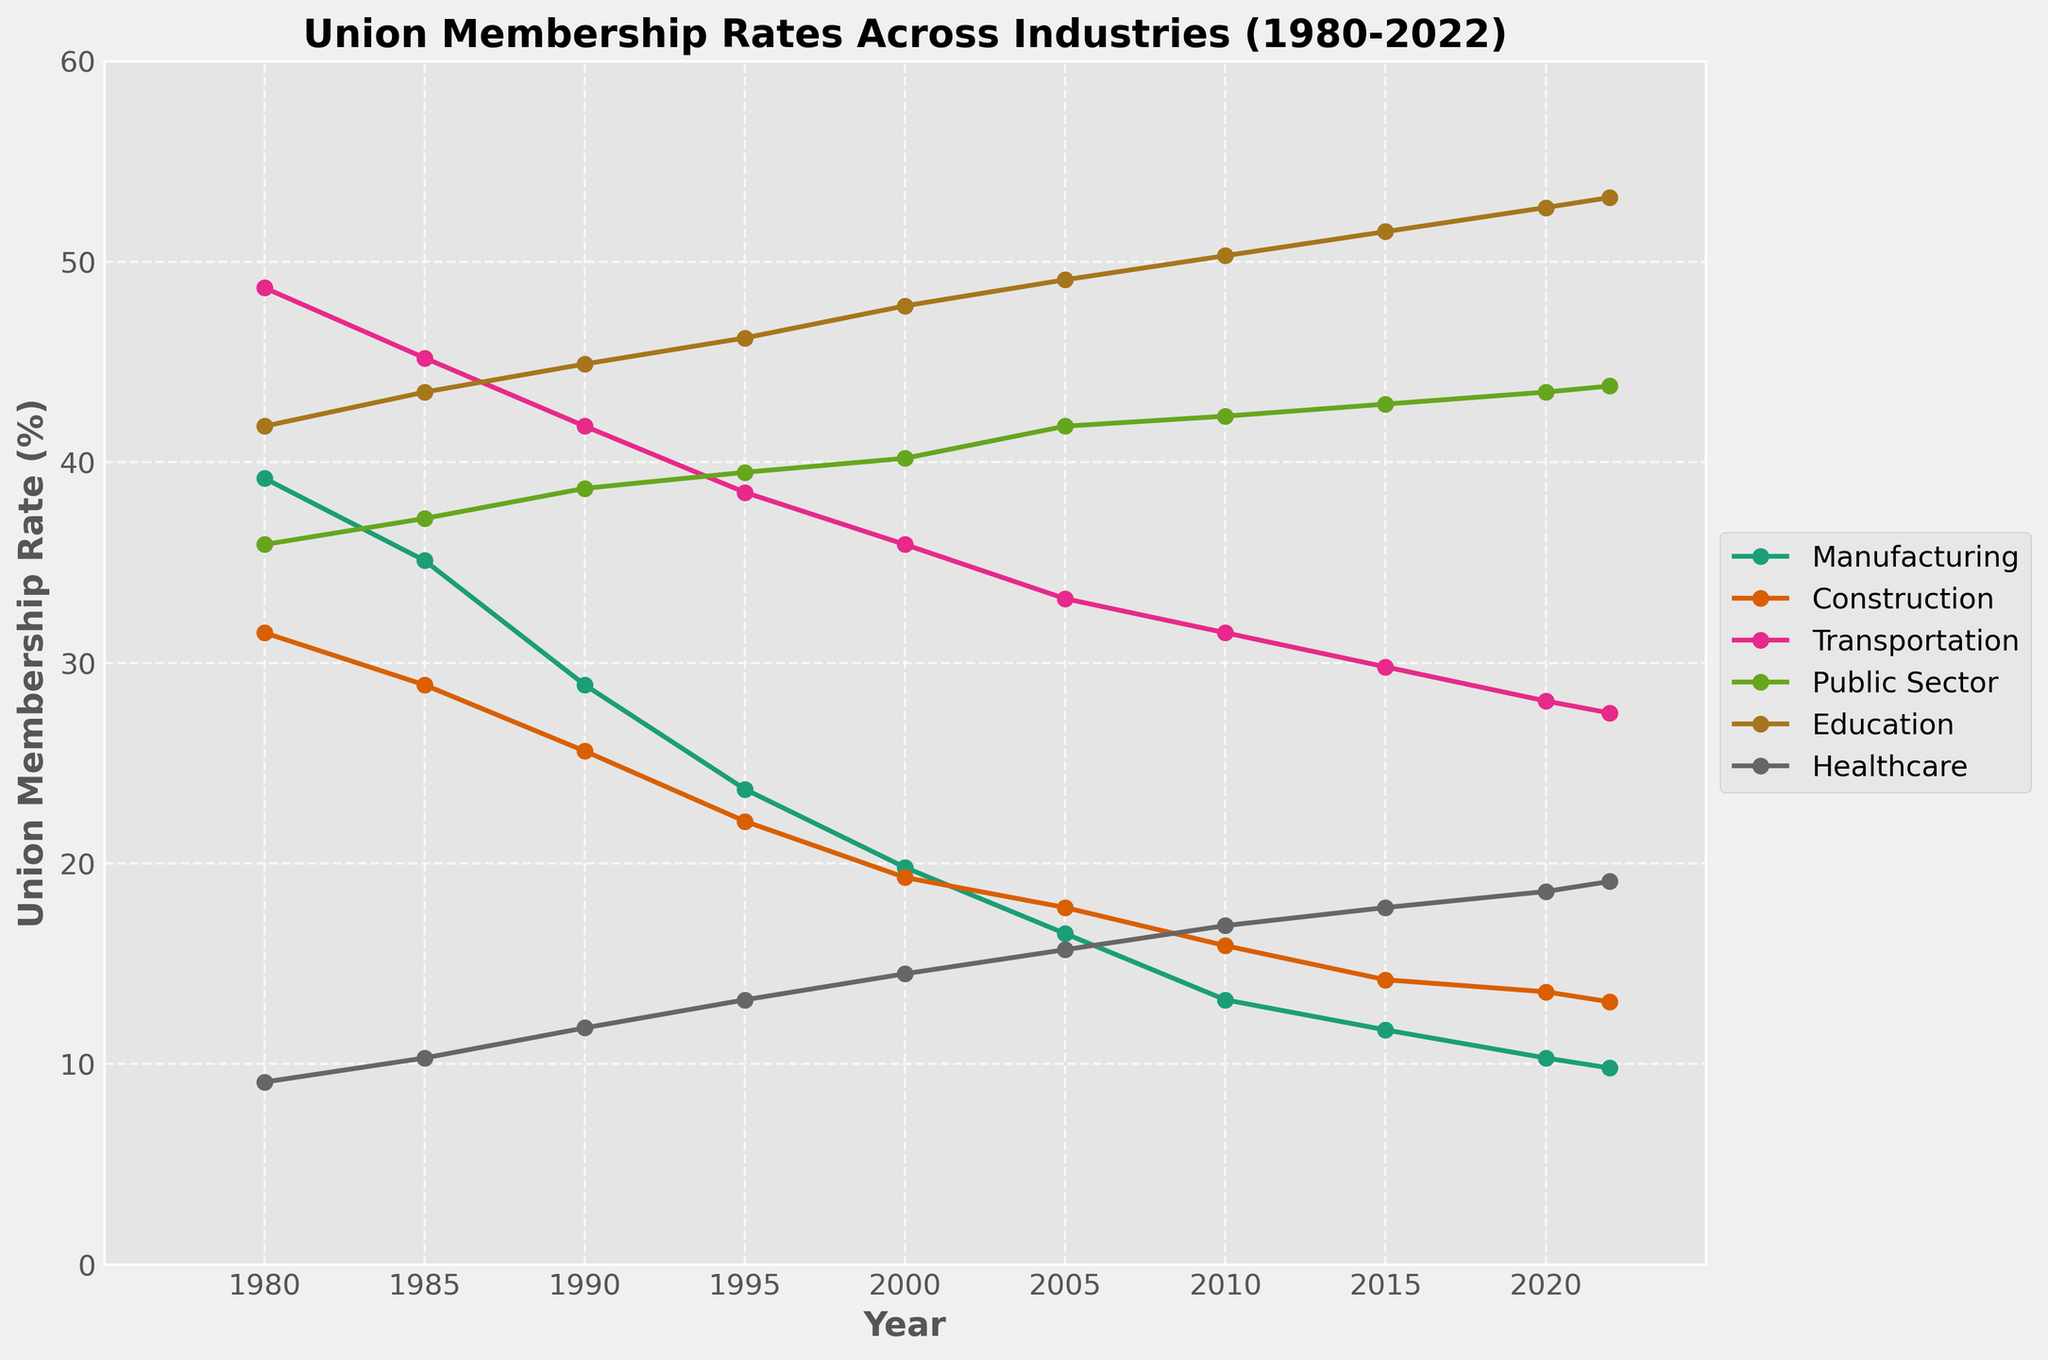What industry had the highest union membership rate in 2022? The highest point on the chart in 2022 corresponds to Education, which is around 53.2%.
Answer: Education In which year did Manufacturing experience the largest decrease in union membership rate compared to the previous year? Calculating the difference year by year, the largest decrease in Manufacturing was between 1985 and 1990, dropping from 35.1% to 28.9% (a 6.2% drop).
Answer: 1985 to 1990 What is the average union membership rate for the Public Sector from 1980 to 2022? Summing the values for the Public Sector (35.9 + 37.2 + 38.7 + 39.5 + 40.2 + 41.8 + 42.3 + 42.9 + 43.5 + 43.8 = 405.8) and dividing by the number of years (10) gives an average of 40.58%.
Answer: 40.58% Compare the union membership rates between Transportation and Healthcare in 2020. Which one was higher and by how much? The rate in Transportation is 28.1%, and in Healthcare, it is 18.6%. The difference is 28.1% - 18.6% = 9.5%.
Answer: Transportation by 9.5% Which industry had the least change in union membership rate from 1980 to 2022? Looking at the start and end points for each industry, Education changed from 41.8% to 53.2% (a 11.4% increase), which is the smallest change compared to other industries.
Answer: Education By how much did the union membership rate in Construction decline from 1980 to 2022? The rate in Construction was 31.5% in 1980 and 13.1% in 2022. The decline is 31.5% - 13.1% = 18.4%.
Answer: 18.4% In which two consecutive periods did Healthcare see the most increase in union membership rate? From 1980 to 1985, the increase is 1.2%, from 1985 to 1990 it is 1.5%, 1990 to 1995 is 1.4%, 1995 to 2000 is 1.3%, 2000 to 2005 is 1.2%, 2005 to 2010 is 1.2%, 2010 to 2015 is 0.9%, 2015 to 2020 is 0.8%, from 2020 to 2022 it is 0.5%. The greatest increase was from 1985 to 1990 (1.5%).
Answer: 1985 to 1990 Identify the industry that had the most consistent increase in union membership rate over the years. Healthcare shows consistent increase from 9.1% in 1980 to 19.1% in 2022 without any decrease in between.
Answer: Healthcare What was the combined union membership rate for Manufacturing and Construction in 1990? Adding the rates for Manufacturing (28.9%) and Construction (25.6%): 28.9% + 25.6% = 54.5%.
Answer: 54.5% Which industry showed a union membership rate of about 11.7% in 2015? According to the plot, the industry with around 11.7% union membership in 2015 is Manufacturing.
Answer: Manufacturing 